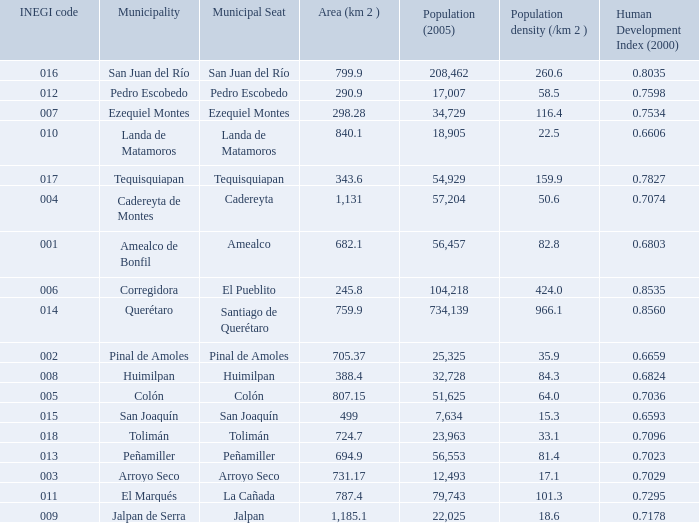WHat is the amount of Human Development Index (2000) that has a Population (2005) of 54,929, and an Area (km 2 ) larger than 343.6? 0.0. 